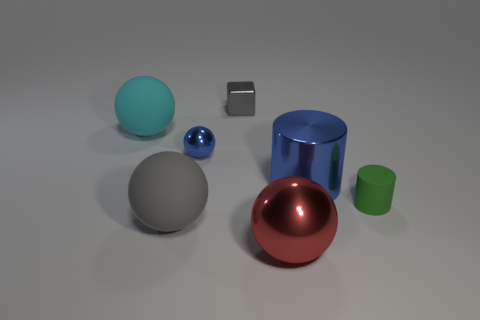Subtract all blue metallic spheres. How many spheres are left? 3 Subtract all gray balls. How many balls are left? 3 Subtract all purple balls. Subtract all green cubes. How many balls are left? 4 Add 2 big yellow shiny cubes. How many objects exist? 9 Subtract all cylinders. How many objects are left? 5 Add 6 small gray metallic cubes. How many small gray metallic cubes are left? 7 Add 4 small green things. How many small green things exist? 5 Subtract 0 yellow cylinders. How many objects are left? 7 Subtract all large red metal spheres. Subtract all small purple metal blocks. How many objects are left? 6 